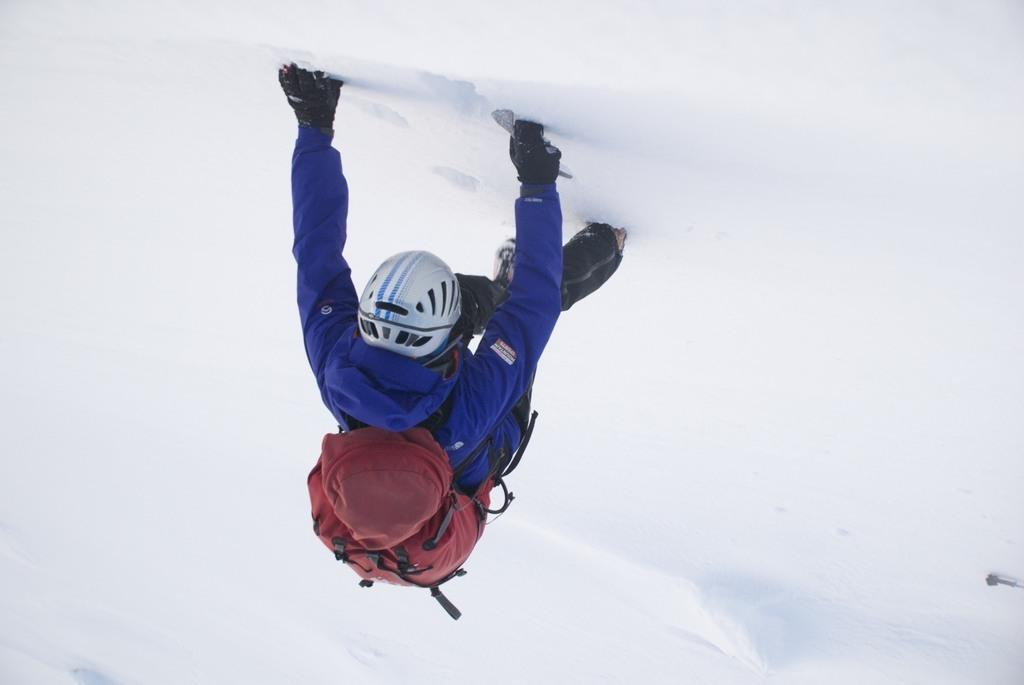What is the main subject of the image? There is a person in the image. What can be observed about the person's attire? The person is wearing clothes, a helmet, and gloves. What is the person carrying in the image? The person is carrying a bag. What type of terrain is the person walking on? The person appears to be walking on the snow. What type of texture can be seen on the geese in the image? There are no geese present in the image; it features a person walking on the snow. How many fish are visible in the image? There are no fish visible in the image. 